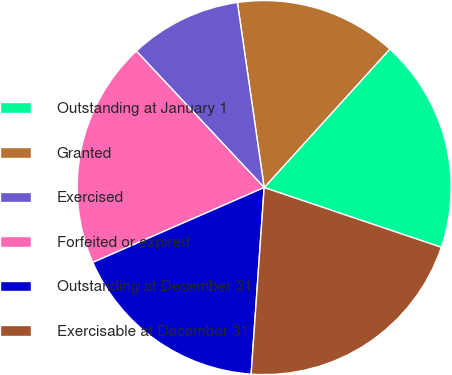<chart> <loc_0><loc_0><loc_500><loc_500><pie_chart><fcel>Outstanding at January 1<fcel>Granted<fcel>Exercised<fcel>Forfeited or expired<fcel>Outstanding at December 31<fcel>Exercisable at December 31<nl><fcel>18.45%<fcel>14.01%<fcel>9.69%<fcel>19.58%<fcel>17.33%<fcel>20.93%<nl></chart> 